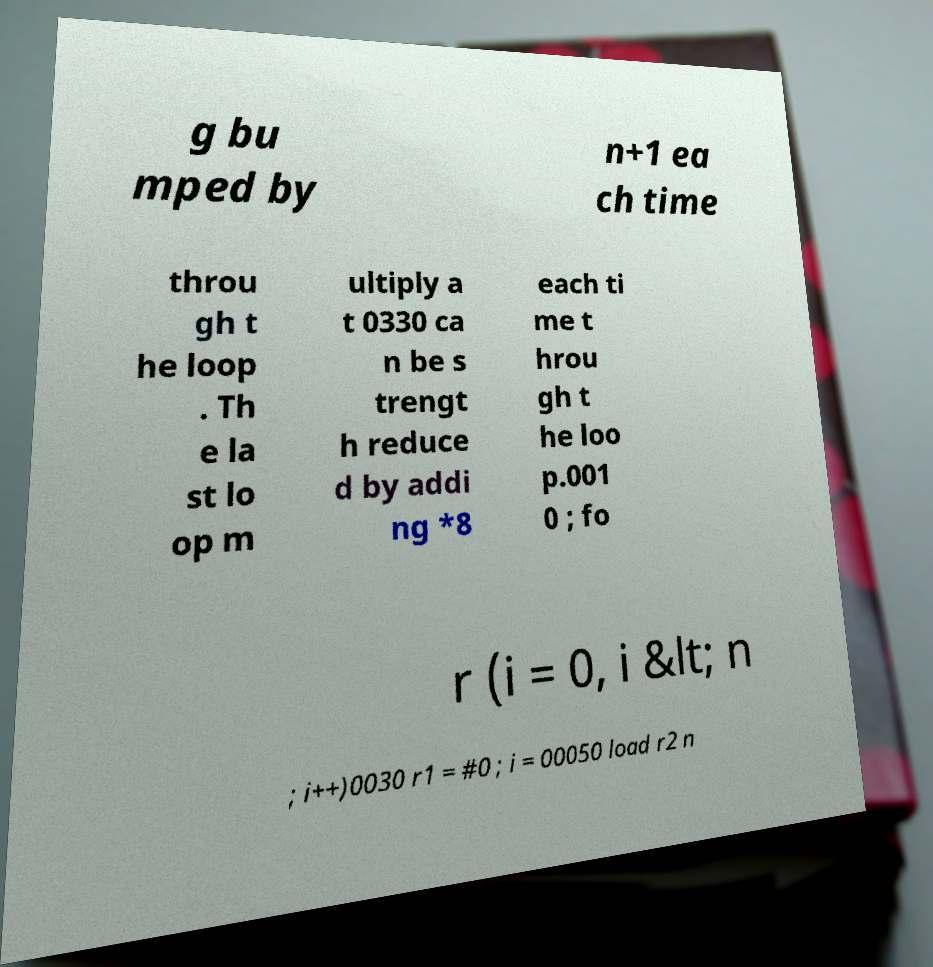Please identify and transcribe the text found in this image. g bu mped by n+1 ea ch time throu gh t he loop . Th e la st lo op m ultiply a t 0330 ca n be s trengt h reduce d by addi ng *8 each ti me t hrou gh t he loo p.001 0 ; fo r (i = 0, i &lt; n ; i++)0030 r1 = #0 ; i = 00050 load r2 n 